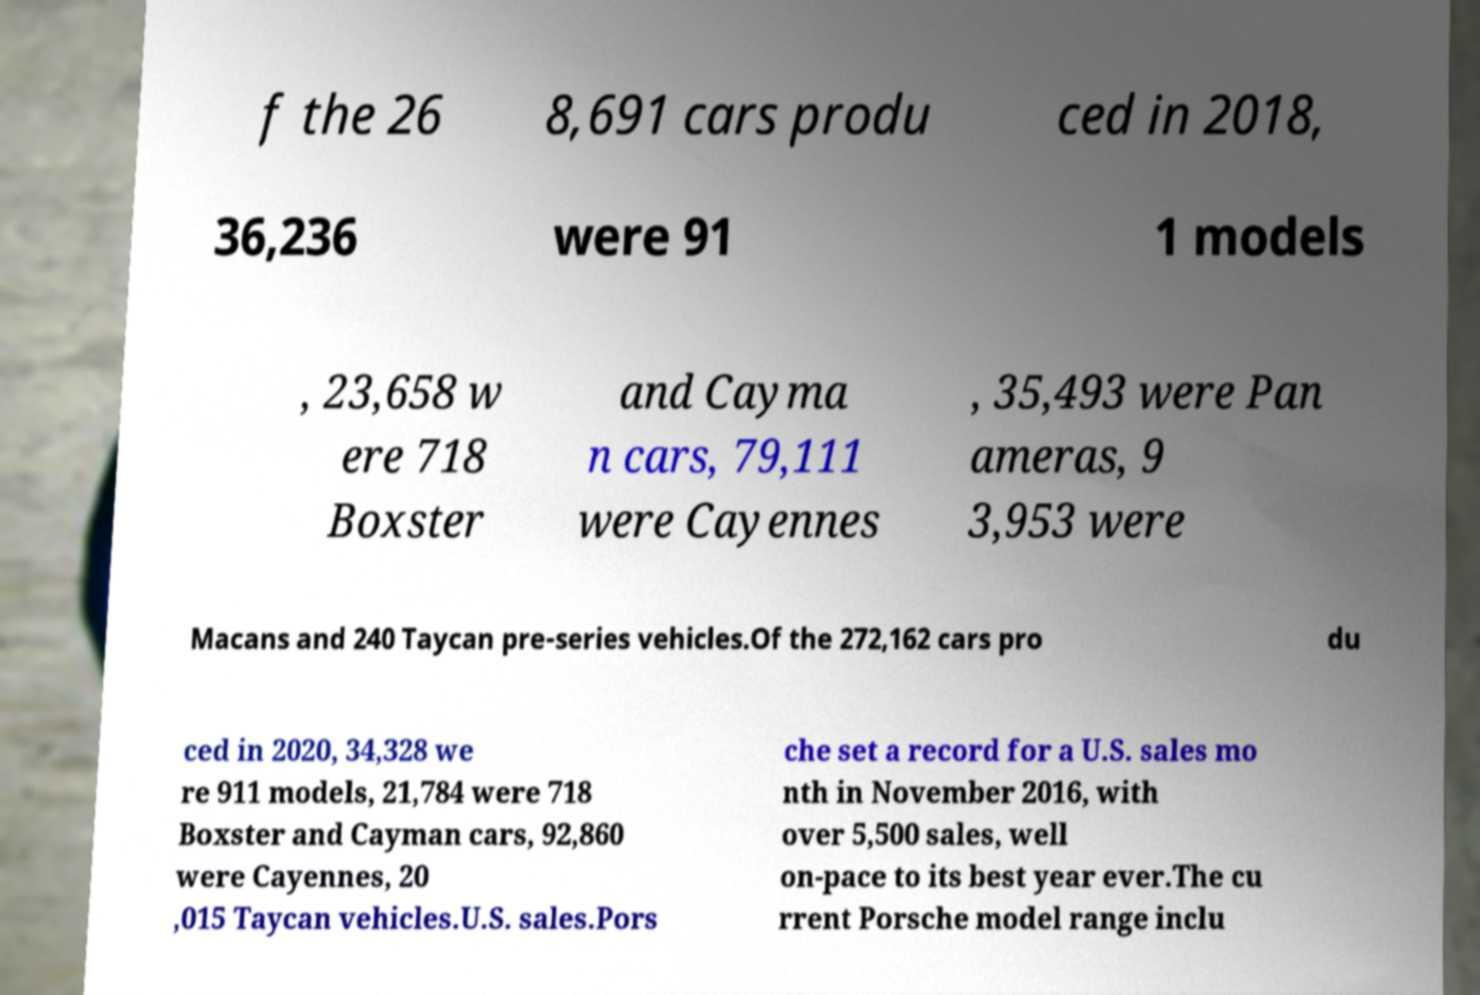Please identify and transcribe the text found in this image. f the 26 8,691 cars produ ced in 2018, 36,236 were 91 1 models , 23,658 w ere 718 Boxster and Cayma n cars, 79,111 were Cayennes , 35,493 were Pan ameras, 9 3,953 were Macans and 240 Taycan pre-series vehicles.Of the 272,162 cars pro du ced in 2020, 34,328 we re 911 models, 21,784 were 718 Boxster and Cayman cars, 92,860 were Cayennes, 20 ,015 Taycan vehicles.U.S. sales.Pors che set a record for a U.S. sales mo nth in November 2016, with over 5,500 sales, well on-pace to its best year ever.The cu rrent Porsche model range inclu 